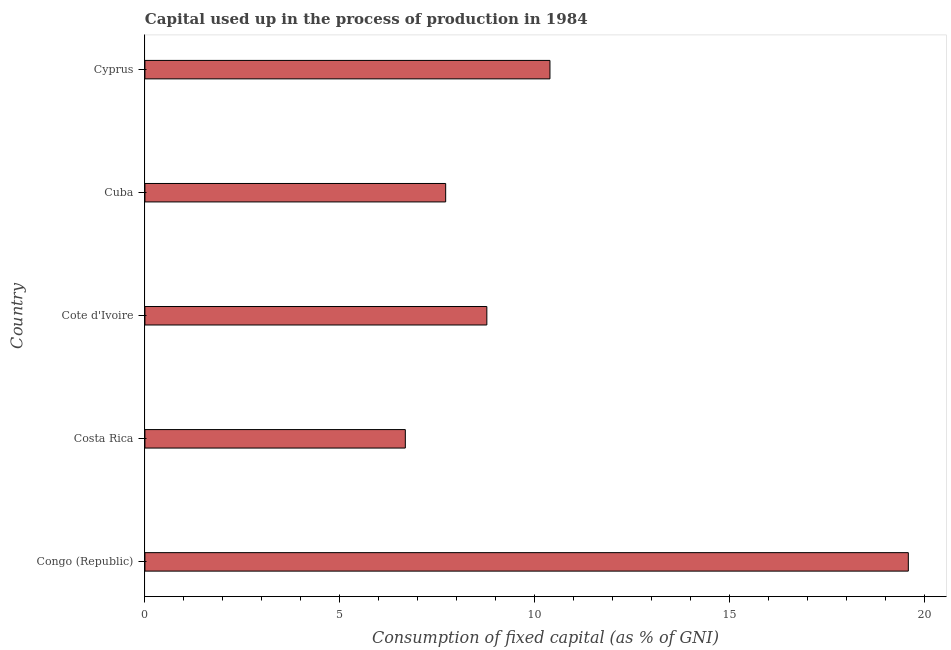Does the graph contain any zero values?
Make the answer very short. No. What is the title of the graph?
Make the answer very short. Capital used up in the process of production in 1984. What is the label or title of the X-axis?
Your answer should be very brief. Consumption of fixed capital (as % of GNI). What is the label or title of the Y-axis?
Your answer should be compact. Country. What is the consumption of fixed capital in Congo (Republic)?
Provide a short and direct response. 19.59. Across all countries, what is the maximum consumption of fixed capital?
Your response must be concise. 19.59. Across all countries, what is the minimum consumption of fixed capital?
Your answer should be compact. 6.68. In which country was the consumption of fixed capital maximum?
Your answer should be very brief. Congo (Republic). In which country was the consumption of fixed capital minimum?
Provide a succinct answer. Costa Rica. What is the sum of the consumption of fixed capital?
Your response must be concise. 53.16. What is the difference between the consumption of fixed capital in Costa Rica and Cuba?
Provide a short and direct response. -1.03. What is the average consumption of fixed capital per country?
Keep it short and to the point. 10.63. What is the median consumption of fixed capital?
Ensure brevity in your answer.  8.77. What is the ratio of the consumption of fixed capital in Congo (Republic) to that in Cyprus?
Provide a succinct answer. 1.89. Is the consumption of fixed capital in Congo (Republic) less than that in Cyprus?
Offer a very short reply. No. What is the difference between the highest and the second highest consumption of fixed capital?
Offer a very short reply. 9.2. Is the sum of the consumption of fixed capital in Cote d'Ivoire and Cuba greater than the maximum consumption of fixed capital across all countries?
Ensure brevity in your answer.  No. What is the difference between the highest and the lowest consumption of fixed capital?
Ensure brevity in your answer.  12.91. Are all the bars in the graph horizontal?
Offer a very short reply. Yes. What is the Consumption of fixed capital (as % of GNI) in Congo (Republic)?
Ensure brevity in your answer.  19.59. What is the Consumption of fixed capital (as % of GNI) of Costa Rica?
Offer a terse response. 6.68. What is the Consumption of fixed capital (as % of GNI) of Cote d'Ivoire?
Give a very brief answer. 8.77. What is the Consumption of fixed capital (as % of GNI) of Cuba?
Make the answer very short. 7.72. What is the Consumption of fixed capital (as % of GNI) of Cyprus?
Give a very brief answer. 10.39. What is the difference between the Consumption of fixed capital (as % of GNI) in Congo (Republic) and Costa Rica?
Your answer should be compact. 12.91. What is the difference between the Consumption of fixed capital (as % of GNI) in Congo (Republic) and Cote d'Ivoire?
Your answer should be very brief. 10.82. What is the difference between the Consumption of fixed capital (as % of GNI) in Congo (Republic) and Cuba?
Your answer should be compact. 11.87. What is the difference between the Consumption of fixed capital (as % of GNI) in Congo (Republic) and Cyprus?
Offer a terse response. 9.2. What is the difference between the Consumption of fixed capital (as % of GNI) in Costa Rica and Cote d'Ivoire?
Your answer should be very brief. -2.09. What is the difference between the Consumption of fixed capital (as % of GNI) in Costa Rica and Cuba?
Your answer should be compact. -1.04. What is the difference between the Consumption of fixed capital (as % of GNI) in Costa Rica and Cyprus?
Keep it short and to the point. -3.71. What is the difference between the Consumption of fixed capital (as % of GNI) in Cote d'Ivoire and Cuba?
Give a very brief answer. 1.06. What is the difference between the Consumption of fixed capital (as % of GNI) in Cote d'Ivoire and Cyprus?
Provide a succinct answer. -1.62. What is the difference between the Consumption of fixed capital (as % of GNI) in Cuba and Cyprus?
Ensure brevity in your answer.  -2.68. What is the ratio of the Consumption of fixed capital (as % of GNI) in Congo (Republic) to that in Costa Rica?
Offer a very short reply. 2.93. What is the ratio of the Consumption of fixed capital (as % of GNI) in Congo (Republic) to that in Cote d'Ivoire?
Provide a succinct answer. 2.23. What is the ratio of the Consumption of fixed capital (as % of GNI) in Congo (Republic) to that in Cuba?
Your answer should be very brief. 2.54. What is the ratio of the Consumption of fixed capital (as % of GNI) in Congo (Republic) to that in Cyprus?
Provide a succinct answer. 1.89. What is the ratio of the Consumption of fixed capital (as % of GNI) in Costa Rica to that in Cote d'Ivoire?
Make the answer very short. 0.76. What is the ratio of the Consumption of fixed capital (as % of GNI) in Costa Rica to that in Cuba?
Your answer should be compact. 0.87. What is the ratio of the Consumption of fixed capital (as % of GNI) in Costa Rica to that in Cyprus?
Offer a very short reply. 0.64. What is the ratio of the Consumption of fixed capital (as % of GNI) in Cote d'Ivoire to that in Cuba?
Keep it short and to the point. 1.14. What is the ratio of the Consumption of fixed capital (as % of GNI) in Cote d'Ivoire to that in Cyprus?
Provide a succinct answer. 0.84. What is the ratio of the Consumption of fixed capital (as % of GNI) in Cuba to that in Cyprus?
Provide a short and direct response. 0.74. 